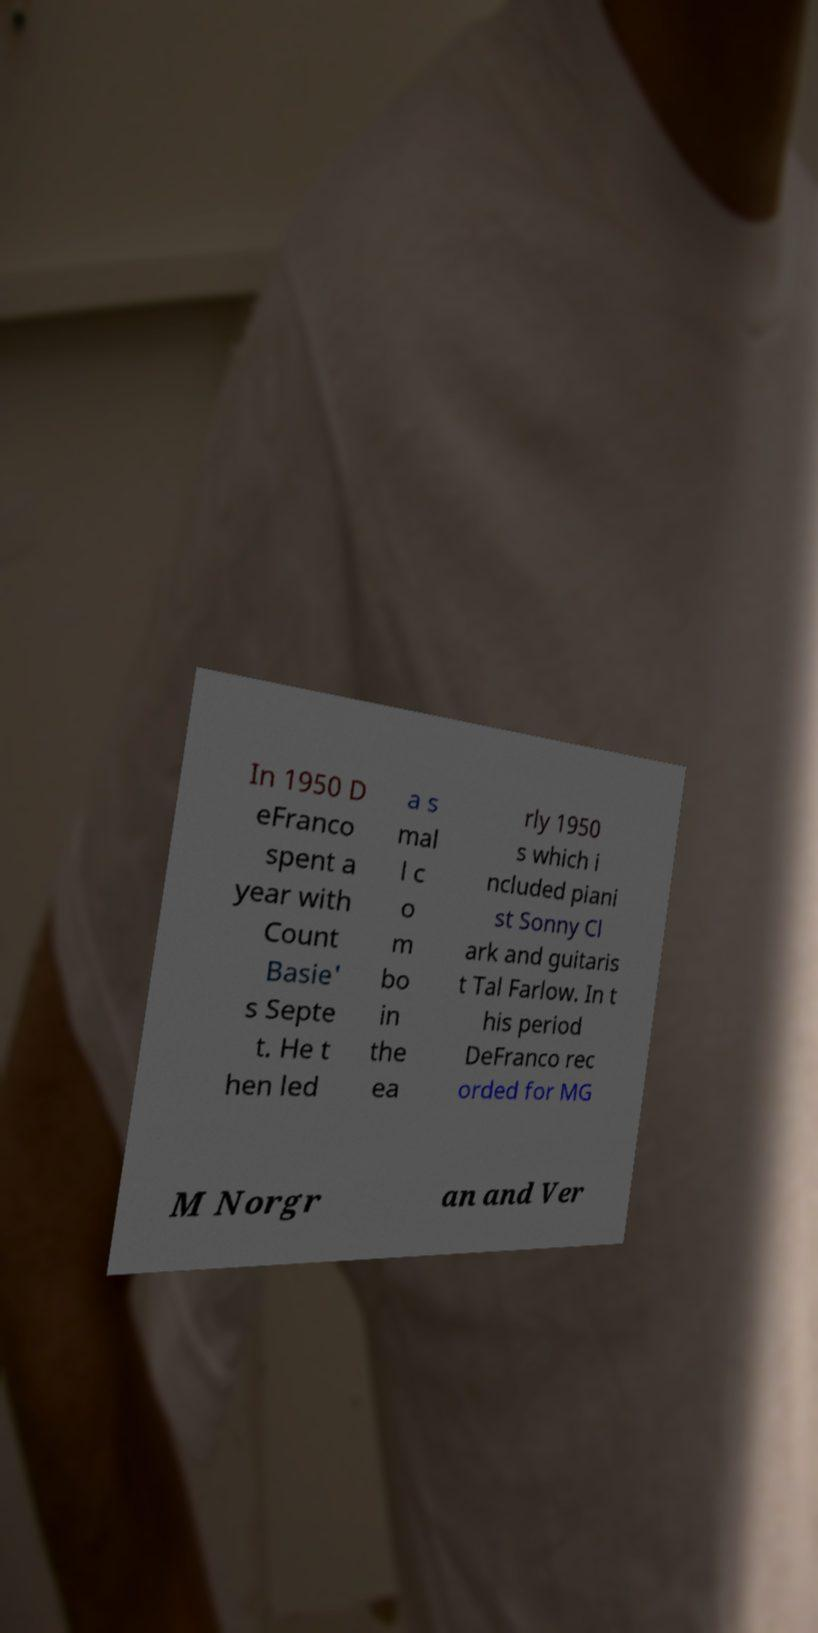There's text embedded in this image that I need extracted. Can you transcribe it verbatim? In 1950 D eFranco spent a year with Count Basie' s Septe t. He t hen led a s mal l c o m bo in the ea rly 1950 s which i ncluded piani st Sonny Cl ark and guitaris t Tal Farlow. In t his period DeFranco rec orded for MG M Norgr an and Ver 